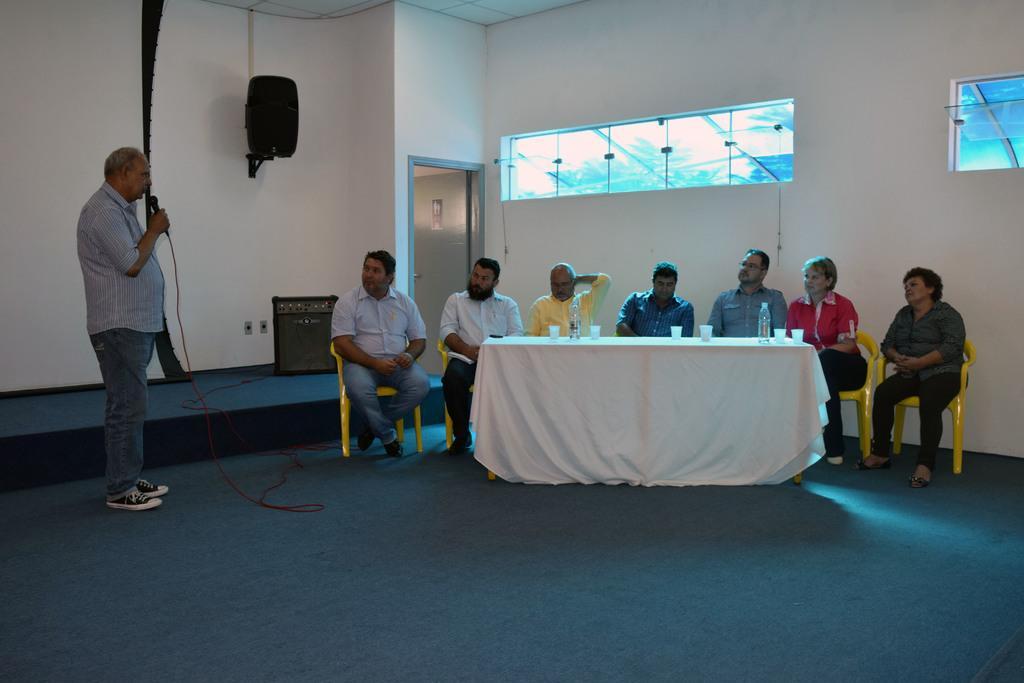In one or two sentences, can you explain what this image depicts? there is a table and a white cloth is placed on it. behind the table people are sitting on the yellow colored chair. on the left side a person is standing , holding a microphone in his hand. behind them there is a wall. on the wall there is a speaker and at the right there is a door. 